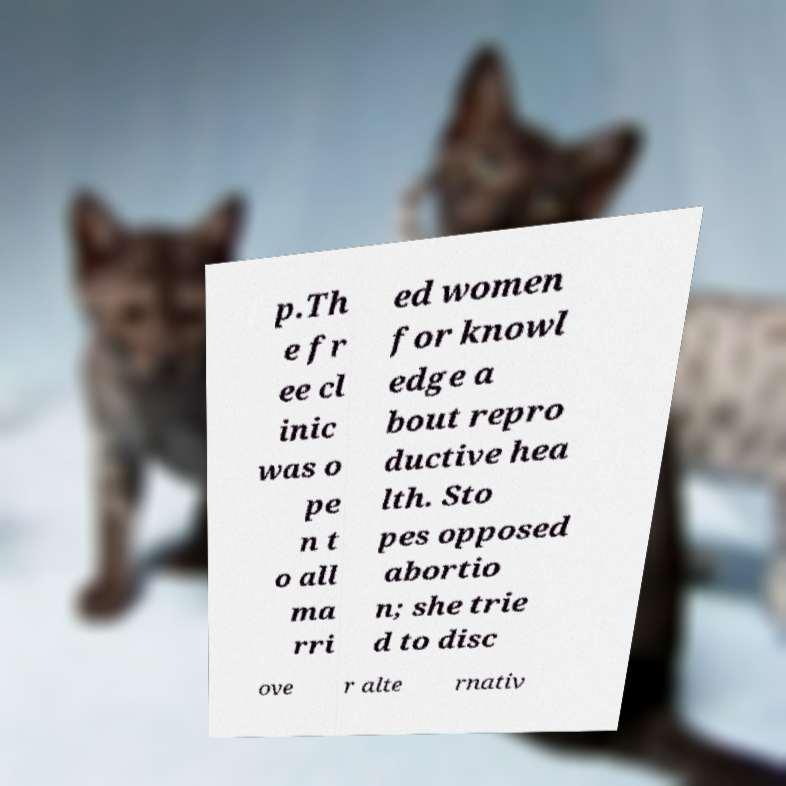Can you read and provide the text displayed in the image?This photo seems to have some interesting text. Can you extract and type it out for me? p.Th e fr ee cl inic was o pe n t o all ma rri ed women for knowl edge a bout repro ductive hea lth. Sto pes opposed abortio n; she trie d to disc ove r alte rnativ 